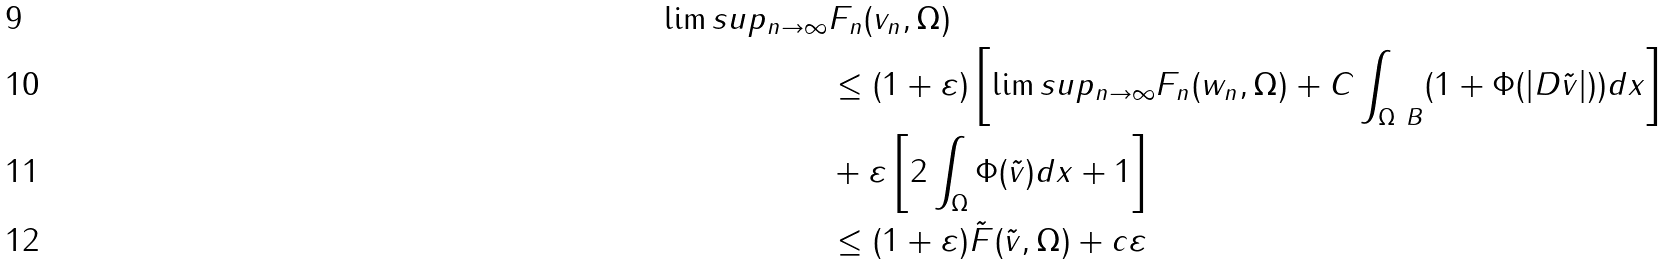<formula> <loc_0><loc_0><loc_500><loc_500>\lim s u p _ { n \rightarrow \infty } & F _ { n } ( v _ { n } , \Omega ) \\ & \leq ( 1 + \varepsilon ) \left [ \lim s u p _ { n \rightarrow \infty } F _ { n } ( w _ { n } , \Omega ) + C \int _ { \Omega \ B } ( 1 + \Phi ( | D \tilde { v } | ) ) d x \right ] \\ & + \varepsilon \left [ 2 \int _ { \Omega } \Phi ( \tilde { v } ) d x + 1 \right ] \\ & \leq ( 1 + \varepsilon ) \tilde { F } ( \tilde { v } , \Omega ) + c \varepsilon</formula> 